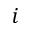Convert formula to latex. <formula><loc_0><loc_0><loc_500><loc_500>i</formula> 